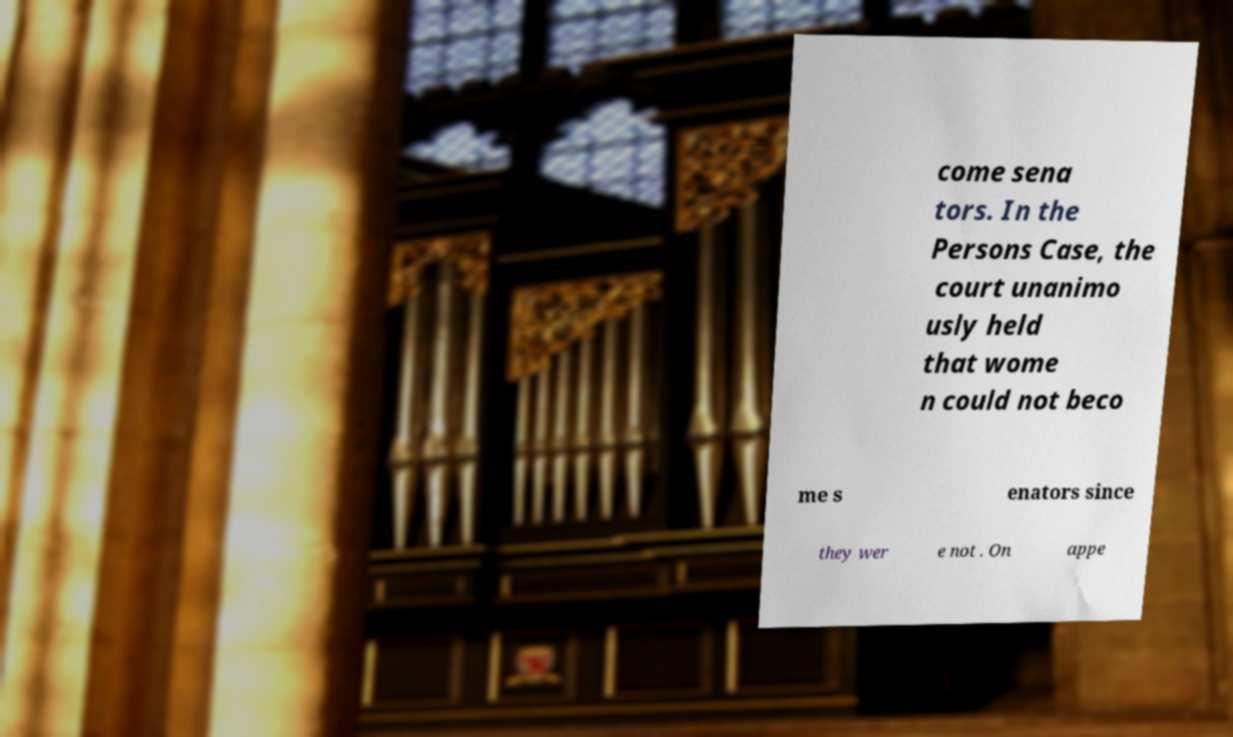Can you accurately transcribe the text from the provided image for me? come sena tors. In the Persons Case, the court unanimo usly held that wome n could not beco me s enators since they wer e not . On appe 